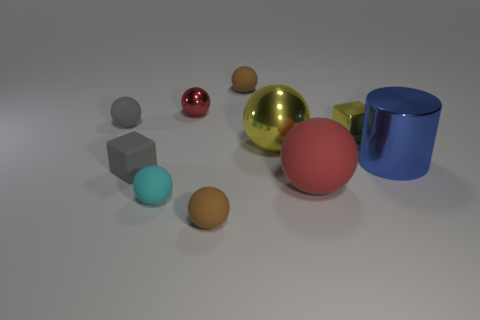How many other things are the same size as the blue metallic cylinder?
Offer a very short reply. 2. What number of balls are both to the right of the small red metal thing and behind the small gray sphere?
Your response must be concise. 1. The brown sphere that is in front of the tiny block left of the metallic object to the left of the large metallic ball is made of what material?
Your answer should be compact. Rubber. What number of yellow objects are made of the same material as the small red ball?
Provide a succinct answer. 2. There is a large matte object that is the same color as the small shiny sphere; what is its shape?
Offer a terse response. Sphere. What shape is the red metal object that is the same size as the matte block?
Provide a succinct answer. Sphere. What is the material of the small thing that is the same color as the matte block?
Provide a succinct answer. Rubber. There is a blue metal cylinder; are there any big blue metallic cylinders to the left of it?
Give a very brief answer. No. Are there any big yellow matte objects of the same shape as the small cyan thing?
Offer a terse response. No. Do the red object that is right of the red metal object and the brown matte thing that is in front of the blue cylinder have the same shape?
Keep it short and to the point. Yes. 